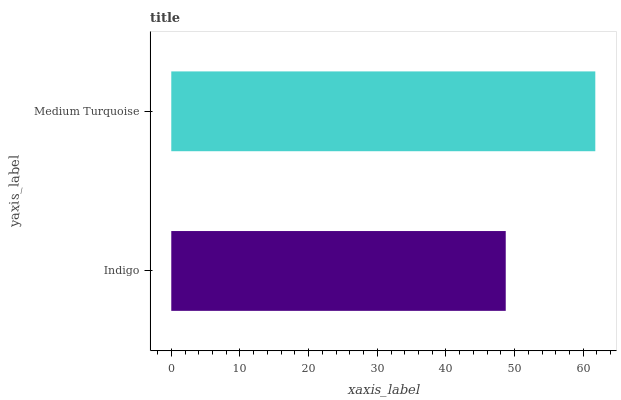Is Indigo the minimum?
Answer yes or no. Yes. Is Medium Turquoise the maximum?
Answer yes or no. Yes. Is Medium Turquoise the minimum?
Answer yes or no. No. Is Medium Turquoise greater than Indigo?
Answer yes or no. Yes. Is Indigo less than Medium Turquoise?
Answer yes or no. Yes. Is Indigo greater than Medium Turquoise?
Answer yes or no. No. Is Medium Turquoise less than Indigo?
Answer yes or no. No. Is Medium Turquoise the high median?
Answer yes or no. Yes. Is Indigo the low median?
Answer yes or no. Yes. Is Indigo the high median?
Answer yes or no. No. Is Medium Turquoise the low median?
Answer yes or no. No. 